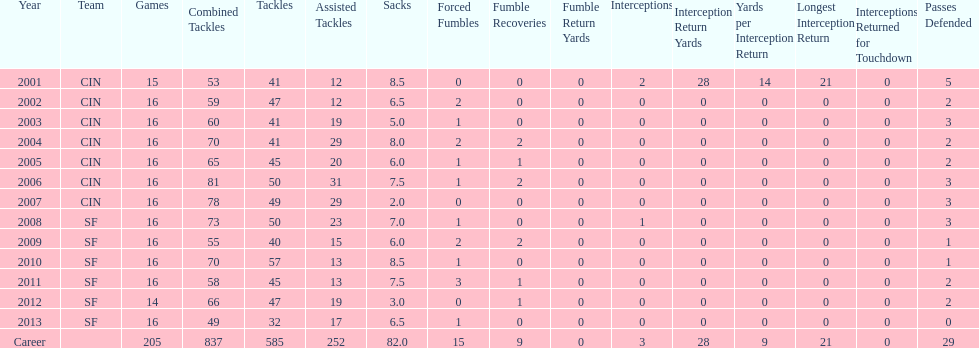How many fumble recoveries did this player have in 2004? 2. 